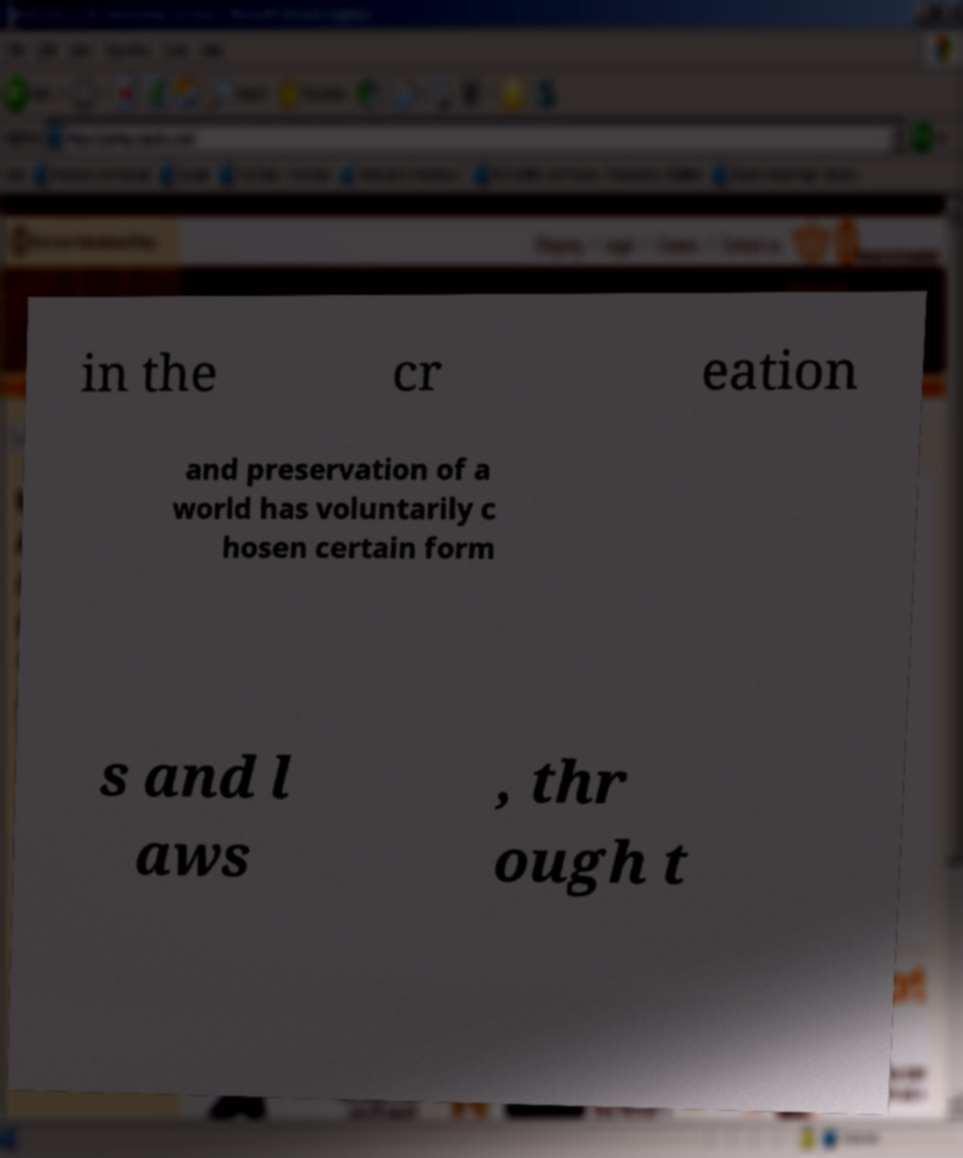Could you extract and type out the text from this image? in the cr eation and preservation of a world has voluntarily c hosen certain form s and l aws , thr ough t 